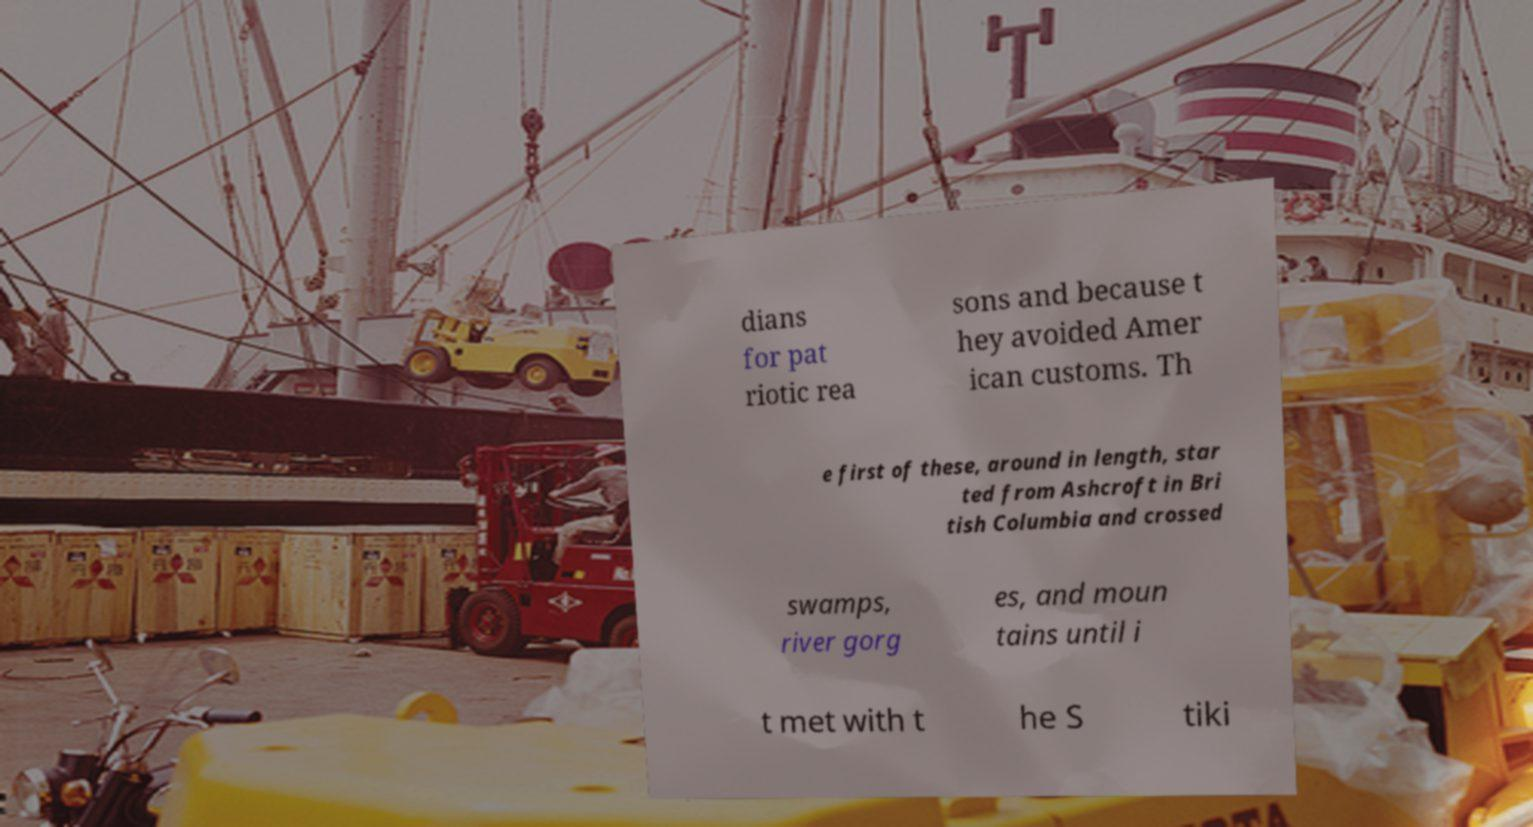Please read and relay the text visible in this image. What does it say? dians for pat riotic rea sons and because t hey avoided Amer ican customs. Th e first of these, around in length, star ted from Ashcroft in Bri tish Columbia and crossed swamps, river gorg es, and moun tains until i t met with t he S tiki 